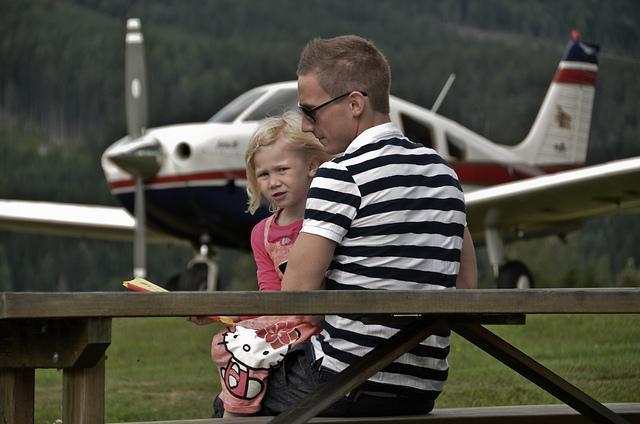What is the thing on the front tip of the airplane?
Make your selection from the four choices given to correctly answer the question.
Options: Whirl, tip, windmill, propeller. Propeller. 